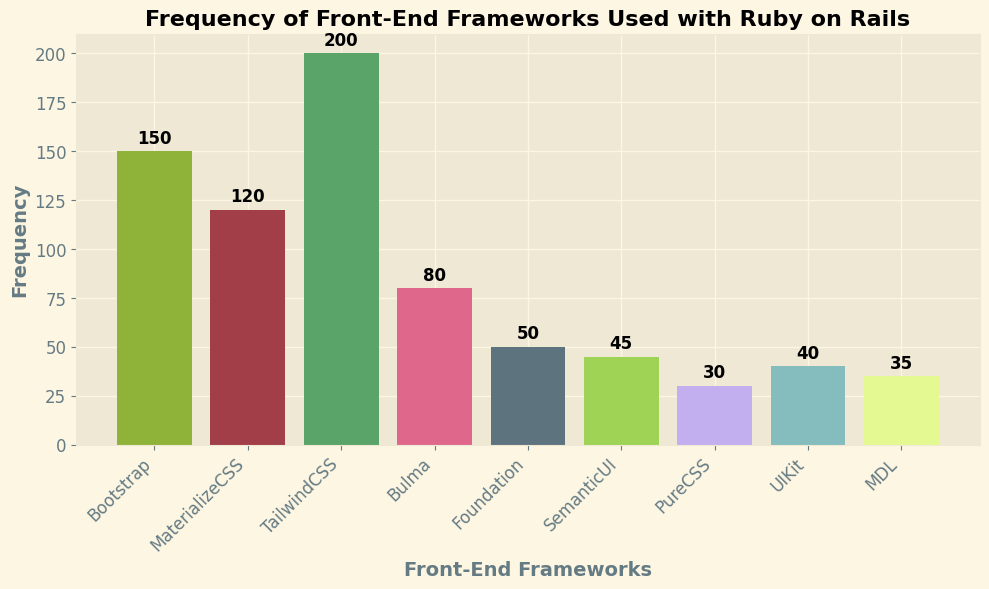What front-end framework is the most frequently used with Ruby on Rails? The bar with the highest height in the figure represents the front-end framework with the highest frequency. In this case, the tallest bar corresponds to TailwindCSS.
Answer: TailwindCSS Which front-end framework has the lowest frequency? The bar with the lowest height in the figure represents the front-end framework with the lowest frequency. In this case, the shortest bar corresponds to PureCSS.
Answer: PureCSS How many more times is Bootstrap used compared to Foundation? To find the difference in frequency between Bootstrap and Foundation, we subtract Foundation's frequency from Bootstrap's frequency: 150 (Bootstrap) - 50 (Foundation) = 100.
Answer: 100 Is MaterializeCSS used more frequently than Bulma? Comparing the heights of the bars representing MaterializeCSS and Bulma, the bar for MaterializeCSS is taller, indicating it is used more frequently.
Answer: Yes What is the combined frequency of the three least used frameworks? The three least used frameworks are PureCSS (30), UIKit (40), and MDL (35). Adding their frequencies: 30 + 40 + 35 = 105.
Answer: 105 Which framework is used 80 times, and what color is its bar? Looking at the figure, the framework used 80 times corresponds to Bulma. The bar is colored in a distinct hue, which we can identify as a specific color present.
Answer: Bulma What is the average frequency of the front-end frameworks used with Ruby on Rails? To find the average, sum up all the frequencies and divide by the number of frameworks. (150 + 120 + 200 + 80 + 50 + 45 + 30 + 40 + 35) / 9 = 750 / 9 ≈ 83.33.
Answer: 83.33 How many frameworks have a frequency greater than 100? Counting the number of bars with heights above the 100 mark, there are three frameworks: Bootstrap, MaterializeCSS, and TailwindCSS.
Answer: 3 Is there a framework with a frequency very close to 120, and what is its name? Observing the figure, the bar height closest to 120 corresponds to MaterializeCSS.
Answer: MaterializeCSS What is the difference in frequency between the most used and the least used front-end framework? The most used framework is TailwindCSS with a frequency of 200, and the least used is PureCSS with 30. The difference is 200 - 30 = 170.
Answer: 170 